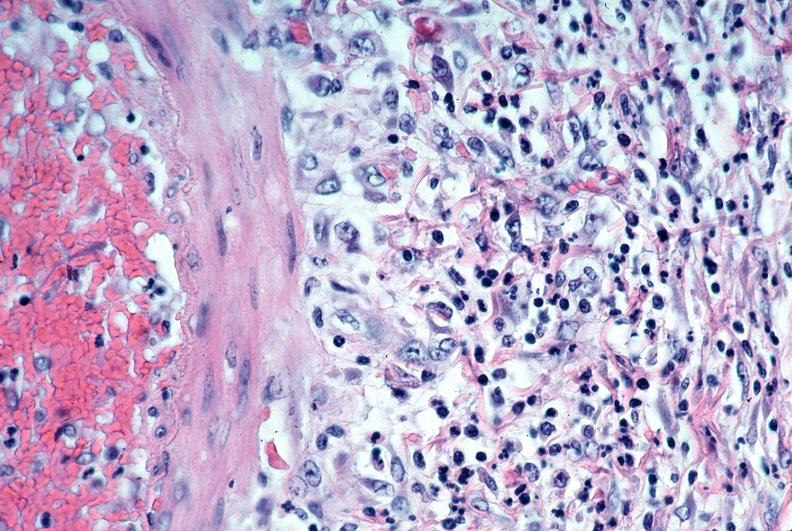s another fiber other frame present?
Answer the question using a single word or phrase. No 